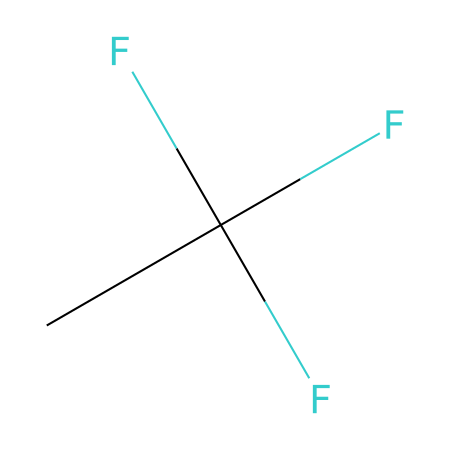What is the total number of carbon atoms in this compound? The SMILES representation shows a single "C" at the beginning followed by a branching structure. There are no additional carbon atoms listed in the SMILES, hence the total is one.
Answer: 1 What is the total number of fluorine atoms in this compound? The SMILES representation shows three "F" atoms in the branching structure after the carbon. Therefore, the total number of fluorine atoms is three.
Answer: 3 What type of chemical is represented by this structure? This compound belongs to the class of hydrofluorocarbons (HFCs), which are characterized by having hydrogen, fluorine, and carbon, typically used as refrigerants.
Answer: hydrofluorocarbon How many hydrogen atoms does this compound contain? The SMILES structure does not explicitly list any hydrogen atoms, and the presence of three fluorine atoms suggests all hydrogens are replaced to form a saturated structure. Hence, there are no hydrogen atoms in this compound.
Answer: 0 What property makes hydrofluorocarbons like this compound more environmentally friendly compared to chlorofluorocarbons (CFCs)? The absence of chlorine in hydrofluorocarbons prevents ozone layer depletion, which is a significant environmental advantage over CFCs that contain chlorine and are known to harm the ozone layer.
Answer: ozone-friendly What is the common use of hydrofluorocarbons like this compound? Hydrofluorocarbons are commonly used as refrigerants in air conditioning and refrigeration systems, providing effective cooling without the harmful effects associated with older refrigerants like CFCs.
Answer: refrigerants What molecular shape does this compound likely adopt? Given the presence of one carbon atom surrounded by three fluorine atoms, the compound exhibits a tetrahedral geometry due to the four substituents around the central carbon atom.
Answer: tetrahedral 